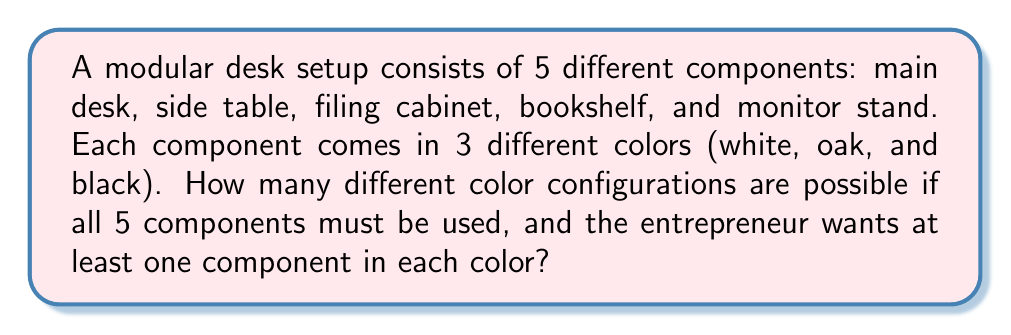Solve this math problem. Let's approach this step-by-step:

1) First, we need to consider the total number of ways to color 5 components with 3 colors:
   $3^5 = 243$ ways

2) However, we need to subtract configurations where one or more colors are not used:

   a) Configurations using only 2 colors:
      $\binom{3}{2} \cdot 2^5 = 3 \cdot 32 = 96$

   b) Configurations using only 1 color:
      $\binom{3}{1} \cdot 1^5 = 3 \cdot 1 = 3$

3) Using the Inclusion-Exclusion Principle:
   Desired configurations = Total - (2 colors only) - (1 color only)
   
   $$ 3^5 - \binom{3}{2} \cdot 2^5 - \binom{3}{1} \cdot 1^5 $$
   $$ = 243 - 96 - 3 = 144 $$

Therefore, there are 144 possible configurations that use all 5 components and include at least one of each color.
Answer: 144 